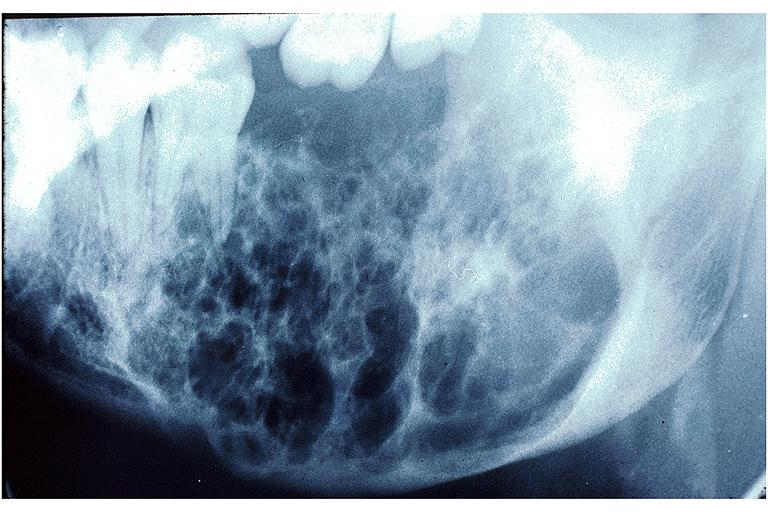does myocardium show ameloblastoma?
Answer the question using a single word or phrase. No 